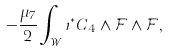<formula> <loc_0><loc_0><loc_500><loc_500>- \frac { \mu _ { 7 } } { 2 } \int _ { \mathcal { W } } \iota ^ { * } C _ { 4 } \wedge \mathcal { F } \wedge \mathcal { F } ,</formula> 